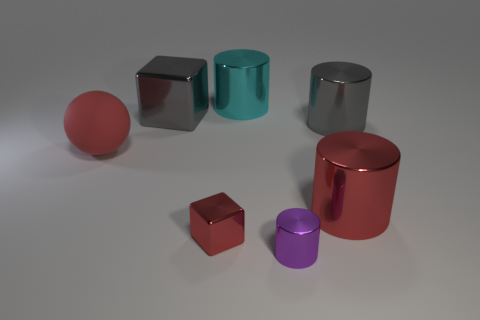Is there any other thing that has the same material as the big ball?
Your answer should be very brief. No. Is there a large metallic object of the same color as the small shiny block?
Your answer should be very brief. Yes. Is the color of the cube behind the large rubber thing the same as the metal thing to the right of the red metallic cylinder?
Offer a terse response. Yes. There is a red object that is both behind the tiny red metal object and right of the red ball; what size is it?
Offer a very short reply. Large. Are there more red objects that are left of the small red shiny block than rubber things that are behind the cyan cylinder?
Keep it short and to the point. Yes. What size is the matte object that is the same color as the small shiny cube?
Keep it short and to the point. Large. The tiny shiny block has what color?
Offer a terse response. Red. What is the color of the metal cylinder that is both behind the small purple thing and in front of the large red rubber sphere?
Your answer should be very brief. Red. What is the color of the big cylinder that is in front of the gray thing on the right side of the block that is in front of the large red cylinder?
Provide a succinct answer. Red. What is the color of the metallic block that is the same size as the red ball?
Give a very brief answer. Gray. 